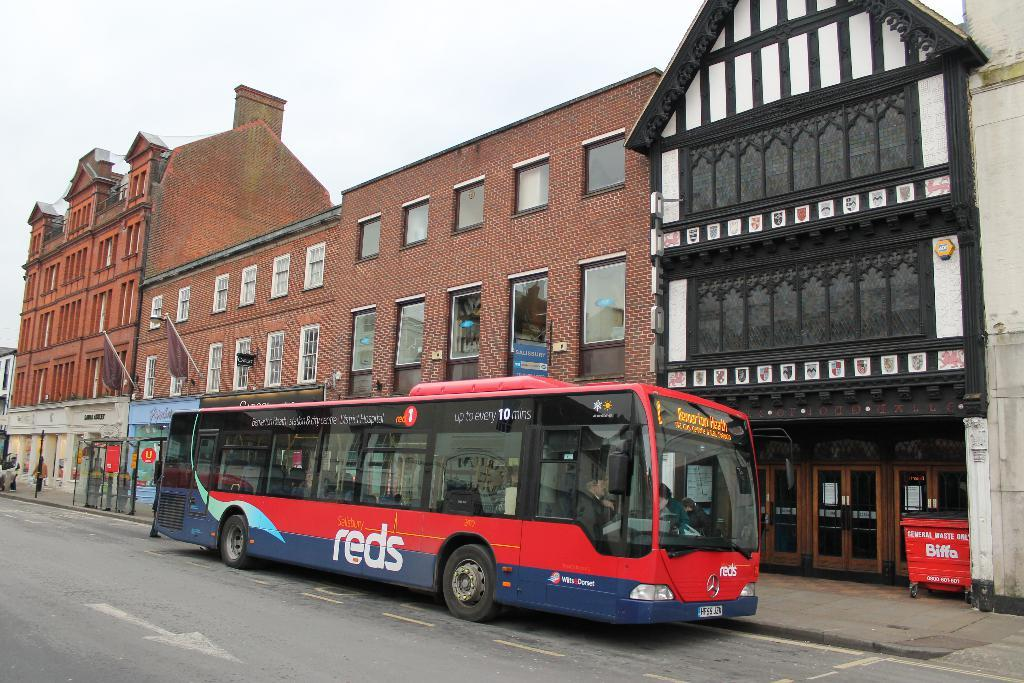What type of structures can be seen in the image? There are buildings in the image. What mode of transportation is the man using in the image? The man is riding a bus at the bottom of the image. Can you identify any specific features of the buildings? There are doors visible in the image. What object is used for waste disposal in the image? A dustbin is present in the image. What is visible at the top of the image? The sky is visible at the top of the image. What type of whip is the fireman using to control the cart in the image? There is no fireman, whip, or cart present in the image. 